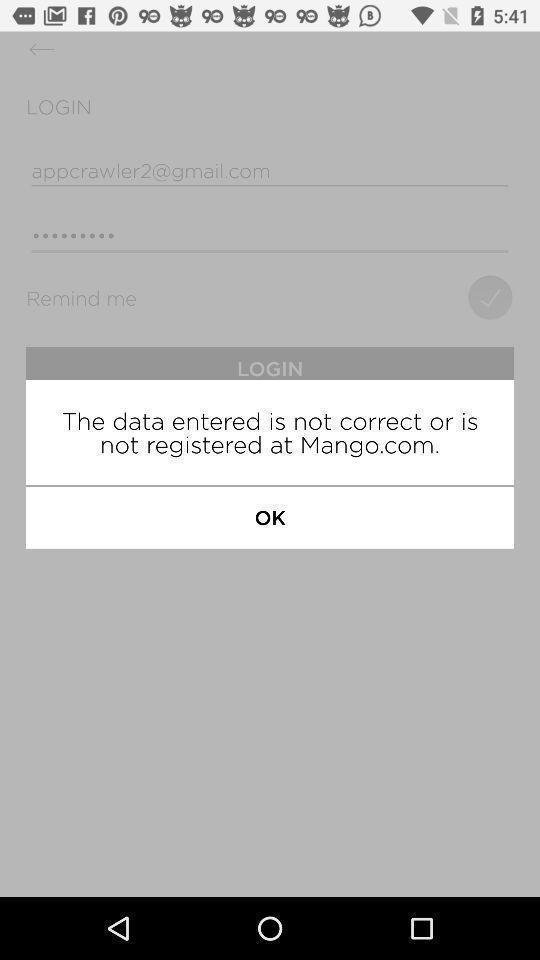Explain the elements present in this screenshot. Pop-up showing data entered is incorrect. 